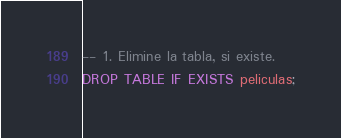<code> <loc_0><loc_0><loc_500><loc_500><_SQL_>-- 1. Elimine la tabla, si existe.
DROP TABLE IF EXISTS peliculas;
</code> 